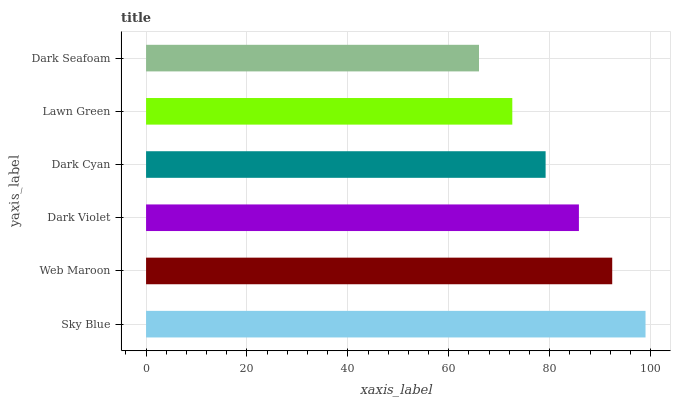Is Dark Seafoam the minimum?
Answer yes or no. Yes. Is Sky Blue the maximum?
Answer yes or no. Yes. Is Web Maroon the minimum?
Answer yes or no. No. Is Web Maroon the maximum?
Answer yes or no. No. Is Sky Blue greater than Web Maroon?
Answer yes or no. Yes. Is Web Maroon less than Sky Blue?
Answer yes or no. Yes. Is Web Maroon greater than Sky Blue?
Answer yes or no. No. Is Sky Blue less than Web Maroon?
Answer yes or no. No. Is Dark Violet the high median?
Answer yes or no. Yes. Is Dark Cyan the low median?
Answer yes or no. Yes. Is Dark Seafoam the high median?
Answer yes or no. No. Is Dark Seafoam the low median?
Answer yes or no. No. 